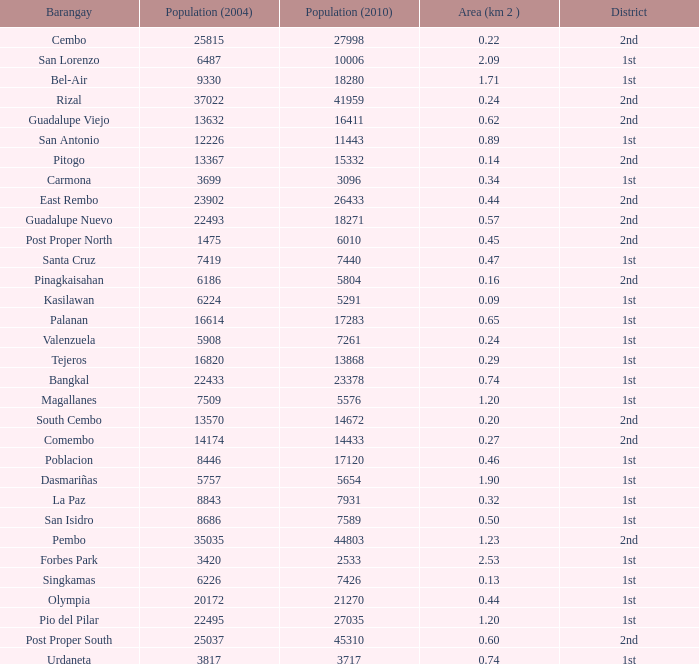Could you help me parse every detail presented in this table? {'header': ['Barangay', 'Population (2004)', 'Population (2010)', 'Area (km 2 )', 'District'], 'rows': [['Cembo', '25815', '27998', '0.22', '2nd'], ['San Lorenzo', '6487', '10006', '2.09', '1st'], ['Bel-Air', '9330', '18280', '1.71', '1st'], ['Rizal', '37022', '41959', '0.24', '2nd'], ['Guadalupe Viejo', '13632', '16411', '0.62', '2nd'], ['San Antonio', '12226', '11443', '0.89', '1st'], ['Pitogo', '13367', '15332', '0.14', '2nd'], ['Carmona', '3699', '3096', '0.34', '1st'], ['East Rembo', '23902', '26433', '0.44', '2nd'], ['Guadalupe Nuevo', '22493', '18271', '0.57', '2nd'], ['Post Proper North', '1475', '6010', '0.45', '2nd'], ['Santa Cruz', '7419', '7440', '0.47', '1st'], ['Pinagkaisahan', '6186', '5804', '0.16', '2nd'], ['Kasilawan', '6224', '5291', '0.09', '1st'], ['Palanan', '16614', '17283', '0.65', '1st'], ['Valenzuela', '5908', '7261', '0.24', '1st'], ['Tejeros', '16820', '13868', '0.29', '1st'], ['Bangkal', '22433', '23378', '0.74', '1st'], ['Magallanes', '7509', '5576', '1.20', '1st'], ['South Cembo', '13570', '14672', '0.20', '2nd'], ['Comembo', '14174', '14433', '0.27', '2nd'], ['Poblacion', '8446', '17120', '0.46', '1st'], ['Dasmariñas', '5757', '5654', '1.90', '1st'], ['La Paz', '8843', '7931', '0.32', '1st'], ['San Isidro', '8686', '7589', '0.50', '1st'], ['Pembo', '35035', '44803', '1.23', '2nd'], ['Forbes Park', '3420', '2533', '2.53', '1st'], ['Singkamas', '6226', '7426', '0.13', '1st'], ['Olympia', '20172', '21270', '0.44', '1st'], ['Pio del Pilar', '22495', '27035', '1.20', '1st'], ['Post Proper South', '25037', '45310', '0.60', '2nd'], ['Urdaneta', '3817', '3717', '0.74', '1st']]} What is the area where barangay is guadalupe viejo? 0.62. 